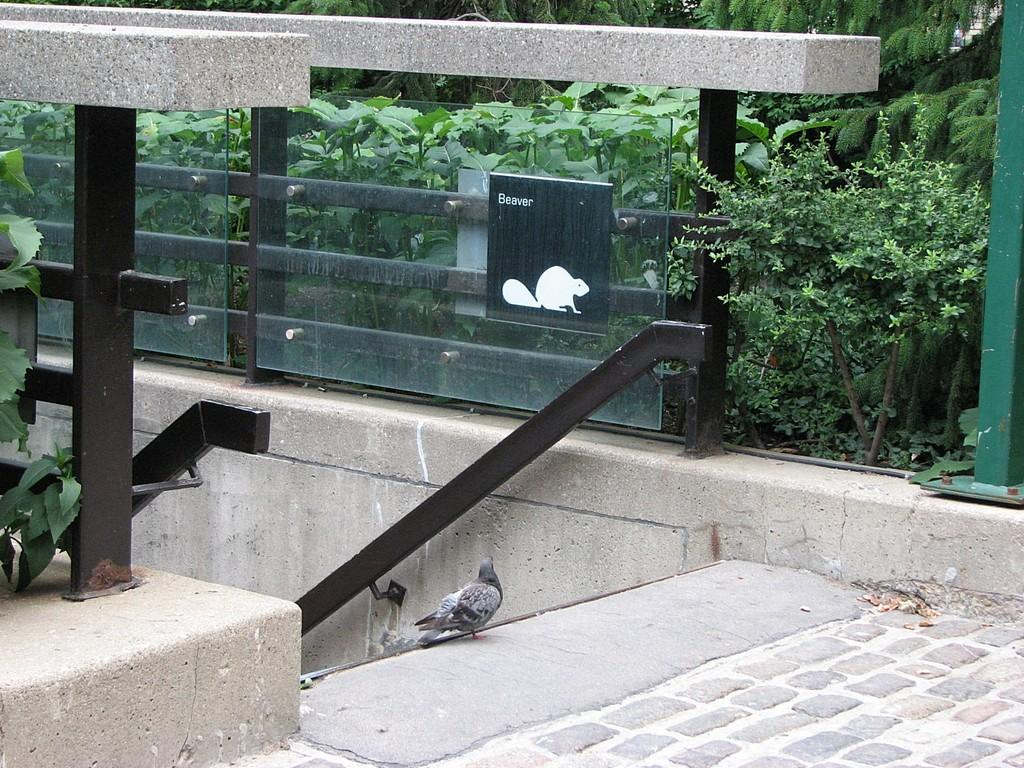What type of animal is in the image? There is a pigeon in the image. Where is the pigeon located? The pigeon is on a walkway. What can be seen in the image besides the pigeon? There is a railing, plants, and a wall in the image. What type of dock can be seen in the image? There is no dock present in the image. How many cows are visible in the image? There are no cows present in the image. 